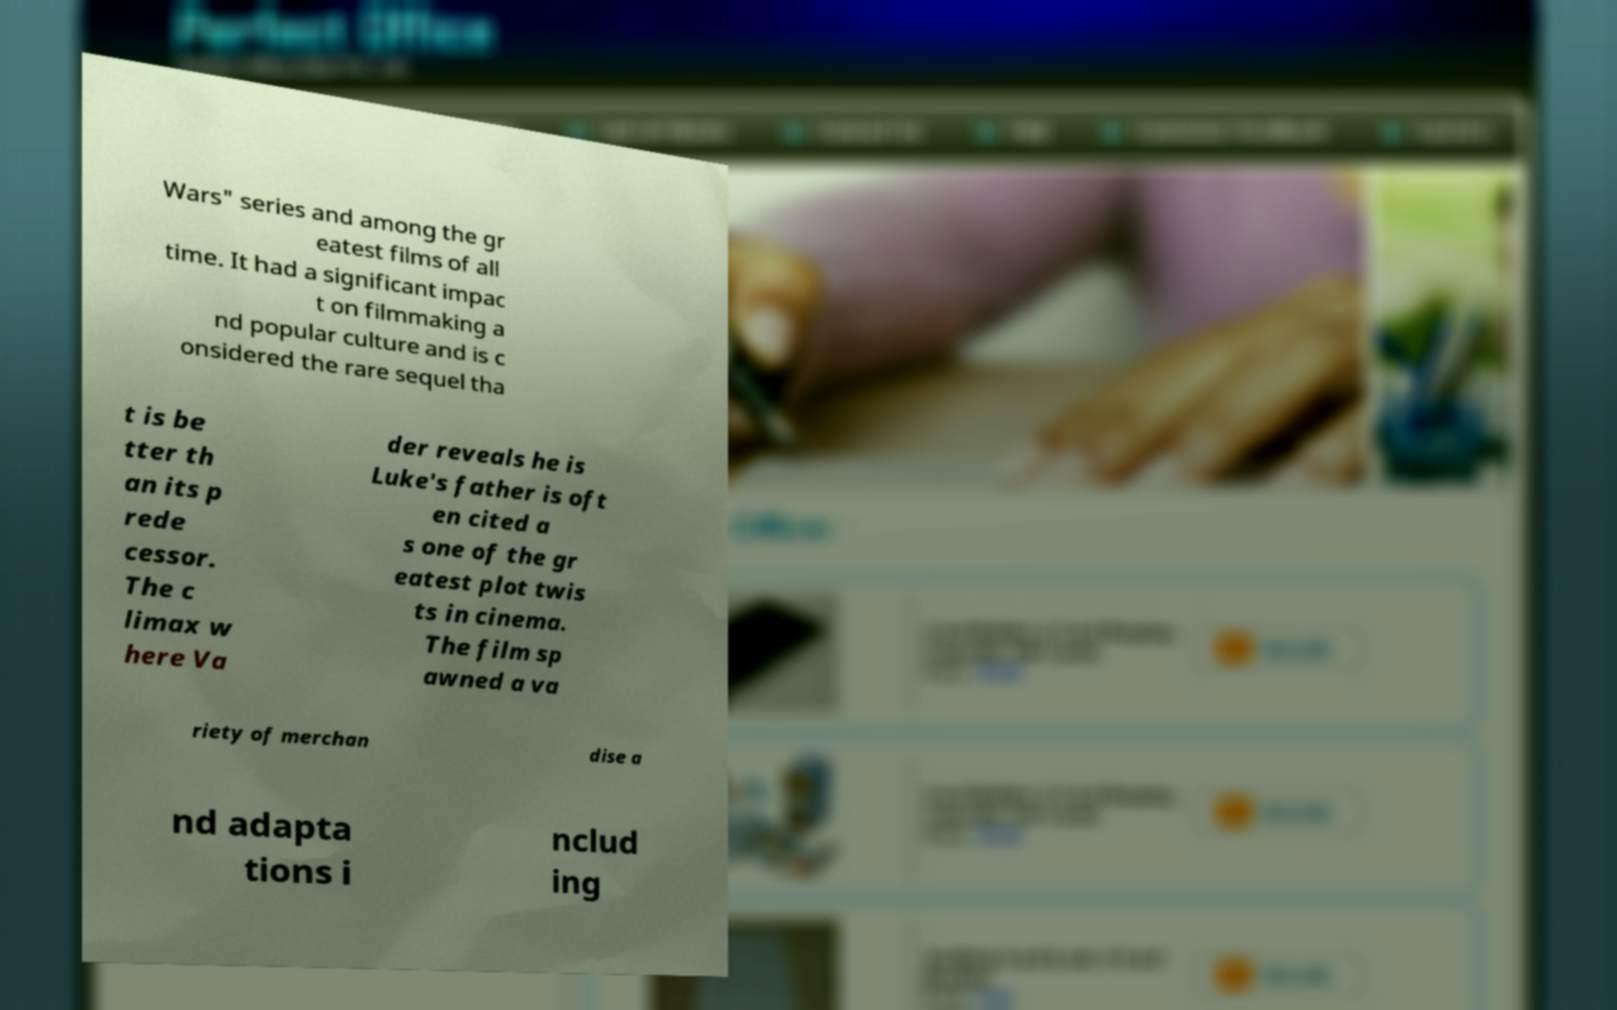Please identify and transcribe the text found in this image. Wars" series and among the gr eatest films of all time. It had a significant impac t on filmmaking a nd popular culture and is c onsidered the rare sequel tha t is be tter th an its p rede cessor. The c limax w here Va der reveals he is Luke's father is oft en cited a s one of the gr eatest plot twis ts in cinema. The film sp awned a va riety of merchan dise a nd adapta tions i nclud ing 